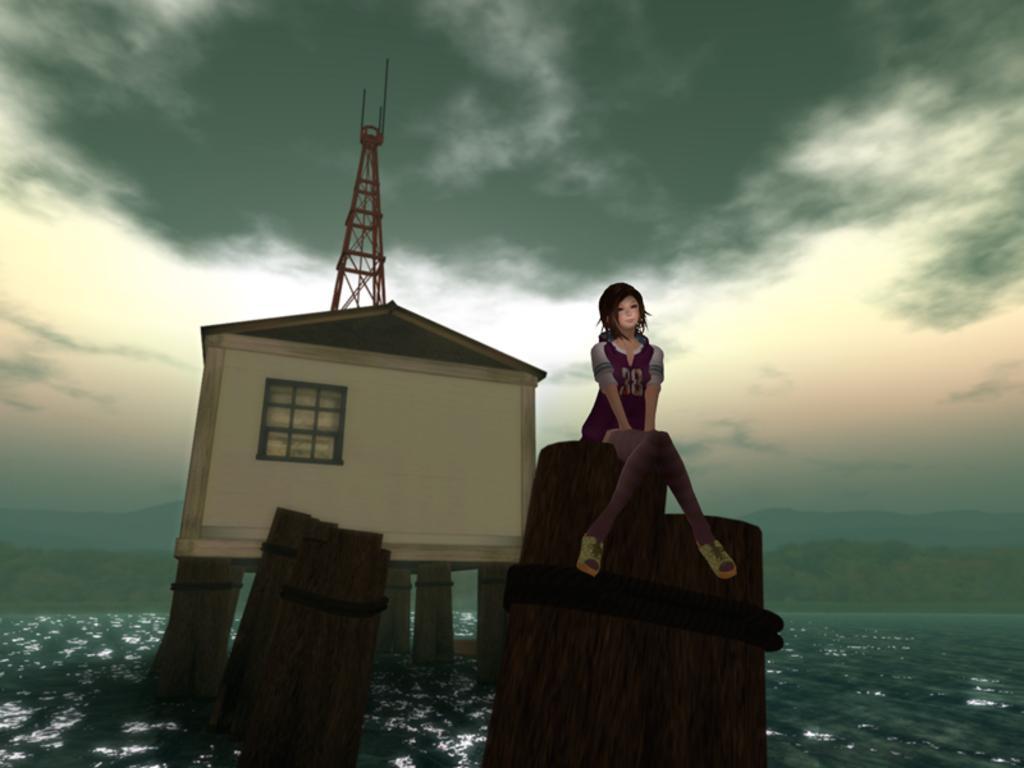Please provide a concise description of this image. In this image we can see the animated picture. And we can see the person, house, wooden logs and the tower on the water. And at the back we can see there are trees and the sky. 